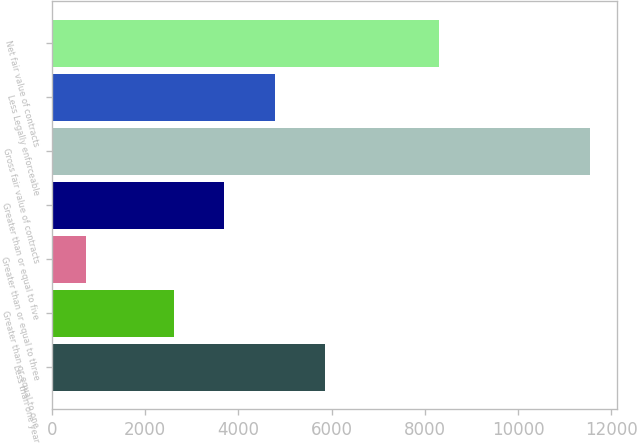Convert chart. <chart><loc_0><loc_0><loc_500><loc_500><bar_chart><fcel>Less than one year<fcel>Greater than or equal to one<fcel>Greater than or equal to three<fcel>Greater than or equal to five<fcel>Gross fair value of contracts<fcel>Less Legally enforceable<fcel>Net fair value of contracts<nl><fcel>5865<fcel>2619<fcel>723<fcel>3701<fcel>11543<fcel>4783<fcel>8299<nl></chart> 